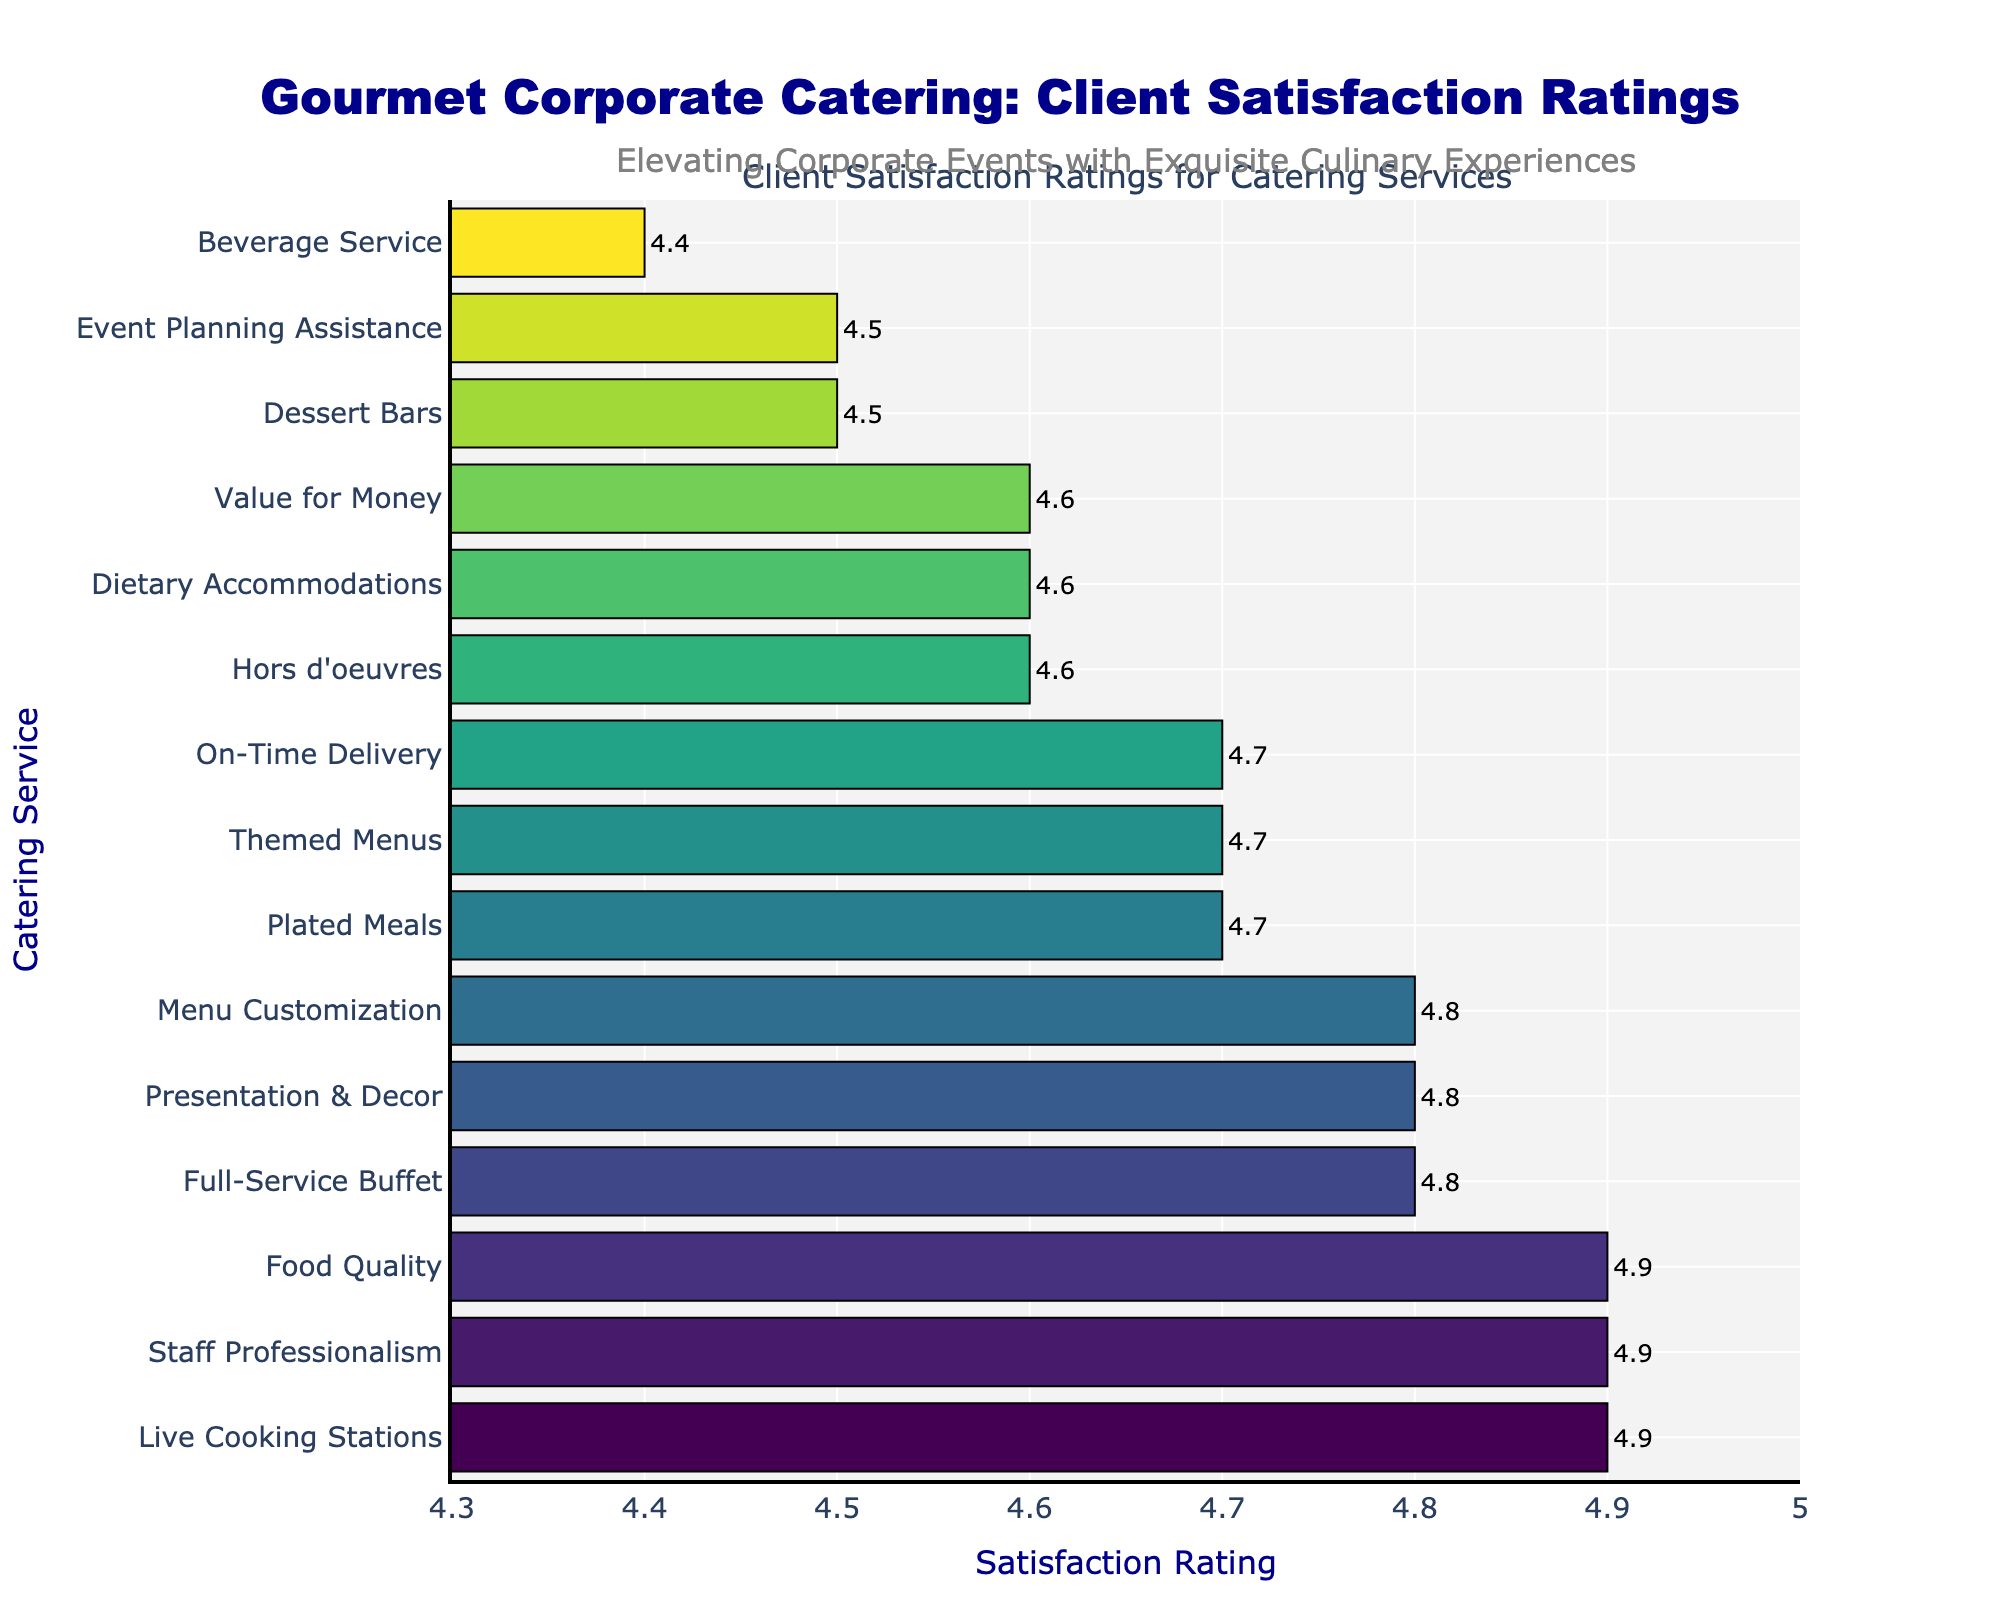What's the highest satisfaction rating shown in the chart? Identify the bar with the highest value on the horizontal axis. It represents "Live Cooking Stations," "Staff Professionalism," and "Food Quality" at a rating of 4.9.
Answer: 4.9 Which service has the lowest satisfaction rating? Locate the bar with the smallest value on the horizontal axis, which is "Beverage Service" with a rating of 4.4.
Answer: Beverage Service How many services received a satisfaction rating of 4.8? Count the bars that align with the value of 4.8 on the horizontal axis. The services are "Full-Service Buffet," "Presentation & Decor," and "Menu Customization."
Answer: 3 What is the total satisfaction rating for "Event Planning Assistance" and "Dessert Bars"? Add the satisfaction ratings of "Event Planning Assistance" (4.5) and "Dessert Bars" (4.5): 4.5 + 4.5 = 9.0
Answer: 9.0 Which service receives a higher rating: "Themed Menus" or "Dietary Accommodations"? Compare the satisfaction ratings of "Themed Menus" (4.7) and "Dietary Accommodations" (4.6). "Themed Menus" has a higher rating.
Answer: Themed Menus What is the average satisfaction rating for the services shown in the chart? Sum all satisfaction ratings and divide by the number of services. (4.8 + 4.7 + 4.6 + 4.9 + 4.5 + 4.4 + 4.7 + 4.6 + 4.8 + 4.9 + 4.7 + 4.8 + 4.9 + 4.6 + 4.5) = 69.4. Divide by 15: 69.4 / 15 ≈ 4.63
Answer: 4.63 Which two services have an equal satisfaction rating? Look for pairs of bars that align horizontally with the same rating. "Plated Meals" and "Themed Menus" both have a rating of 4.7; "Dietary Accommodations" and "Hors d'oeuvres" both have a rating of 4.6.
Answer: Plated Meals and Themed Menus Is the satisfaction rating for "Menu Customization" higher or lower than "Value for Money"? Compare the satisfaction ratings of "Menu Customization" (4.8) and "Value for Money" (4.6). "Menu Customization" has a higher rating.
Answer: Higher Which service lies exactly in the middle of the sorted satisfaction ratings? Identify the middle value when the ratings are sorted. The sorted ratings are 4.4, 4.5, 4.5, 4.6, 4.6, 4.7, 4.7, 4.7, 4.8, 4.8, 4.8, 4.9, 4.9, 4.9. The middle value is the 8th item, which is "On-Time Delivery" at 4.7.
Answer: On-Time Delivery 